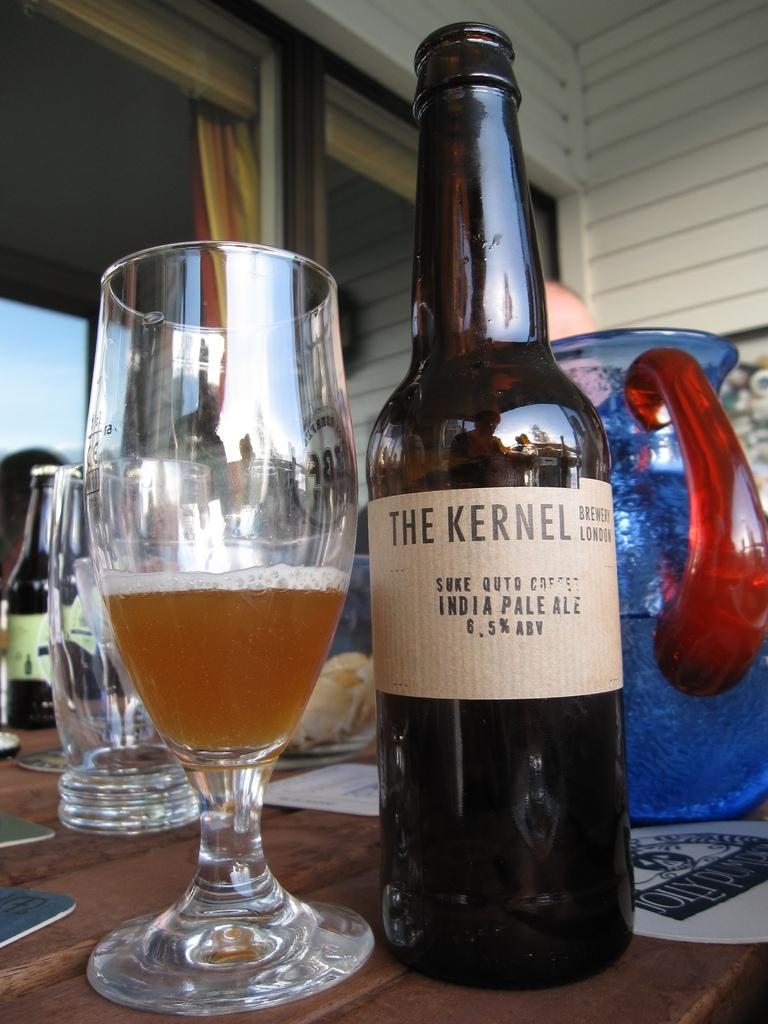Provide a one-sentence caption for the provided image. A bottle of beer sits bya half full glass from The Kernel Brewery London. 